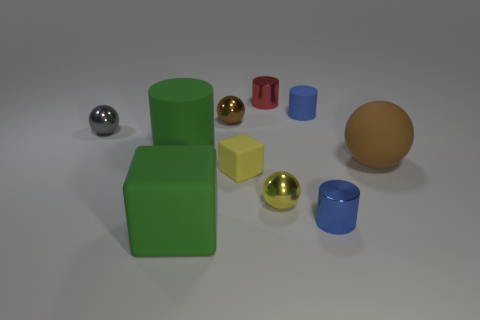Subtract all cylinders. How many objects are left? 6 Subtract 1 red cylinders. How many objects are left? 9 Subtract all small blue things. Subtract all yellow matte objects. How many objects are left? 7 Add 4 tiny blue matte cylinders. How many tiny blue matte cylinders are left? 5 Add 10 large cyan cylinders. How many large cyan cylinders exist? 10 